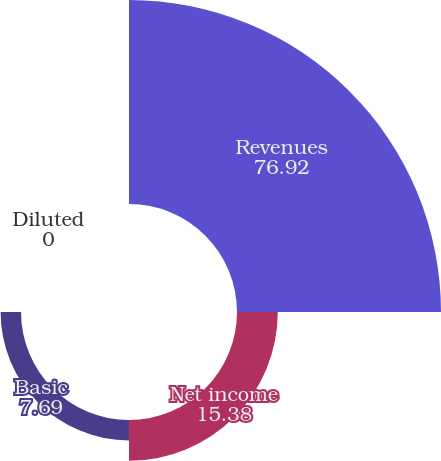<chart> <loc_0><loc_0><loc_500><loc_500><pie_chart><fcel>Revenues<fcel>Net income<fcel>Basic<fcel>Diluted<nl><fcel>76.92%<fcel>15.38%<fcel>7.69%<fcel>0.0%<nl></chart> 